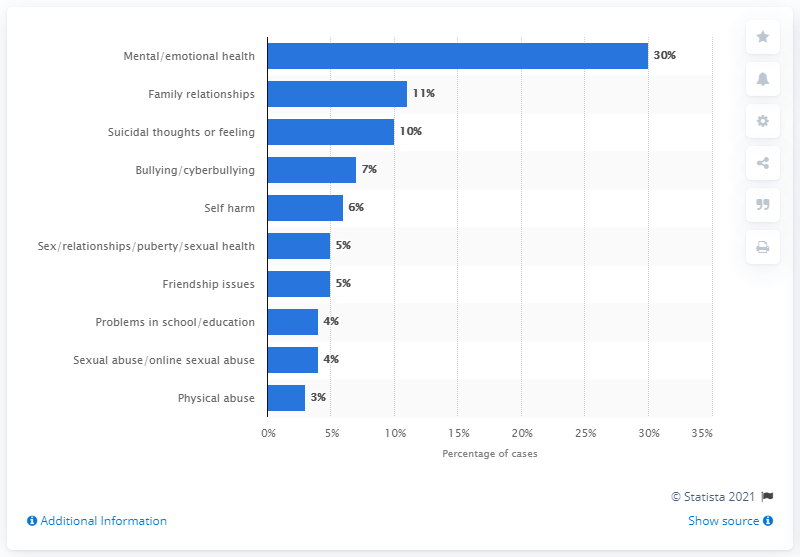Point out several critical features in this image. According to data from 2018/19, concerns over family relationships accounted for approximately 11% of cases. 